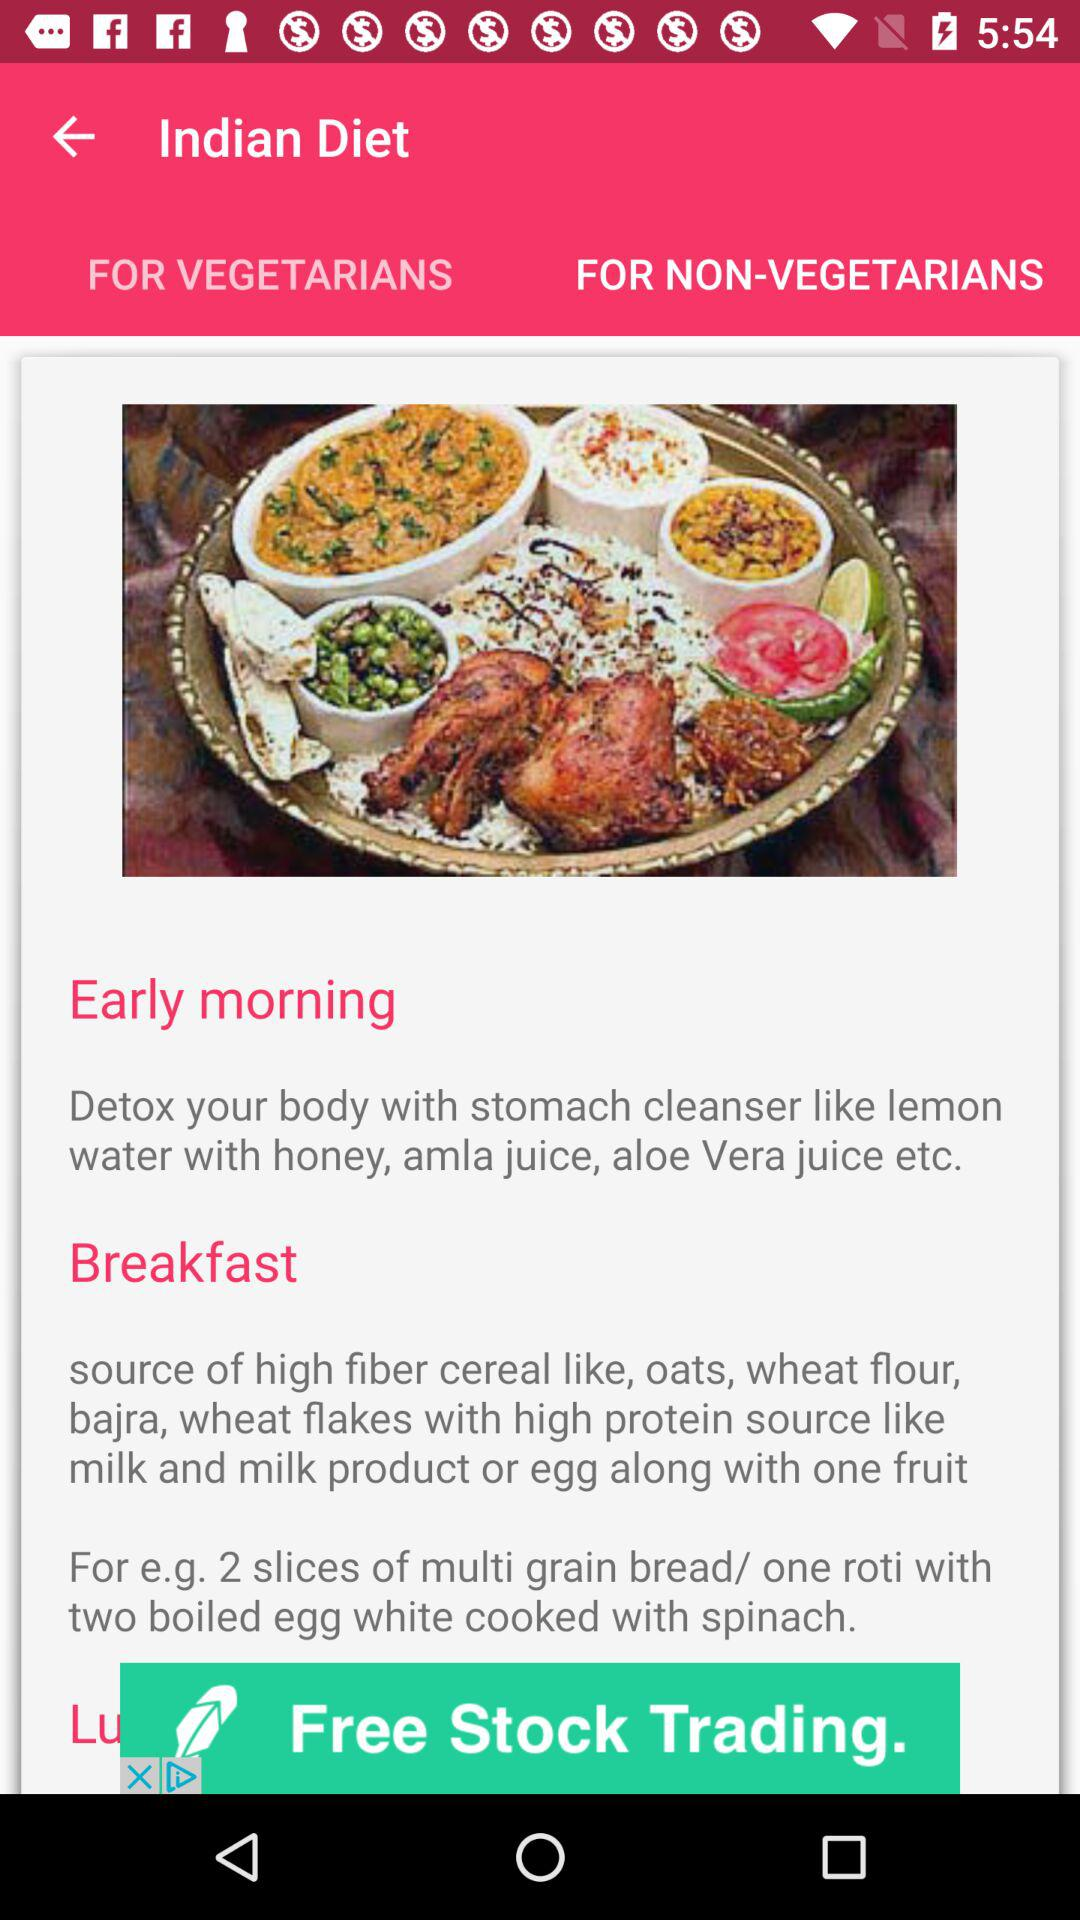Which tab is selected? The selected tab is "FOR NON-VEGETARIANS". 